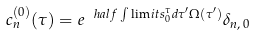<formula> <loc_0><loc_0><loc_500><loc_500>c _ { n } ^ { ( 0 ) } ( \tau ) = e ^ { \ h a l f \int \lim i t s _ { 0 } ^ { \tau } d \tau ^ { \prime } \Omega ( \tau ^ { \prime } ) } \delta _ { n , \, 0 }</formula> 